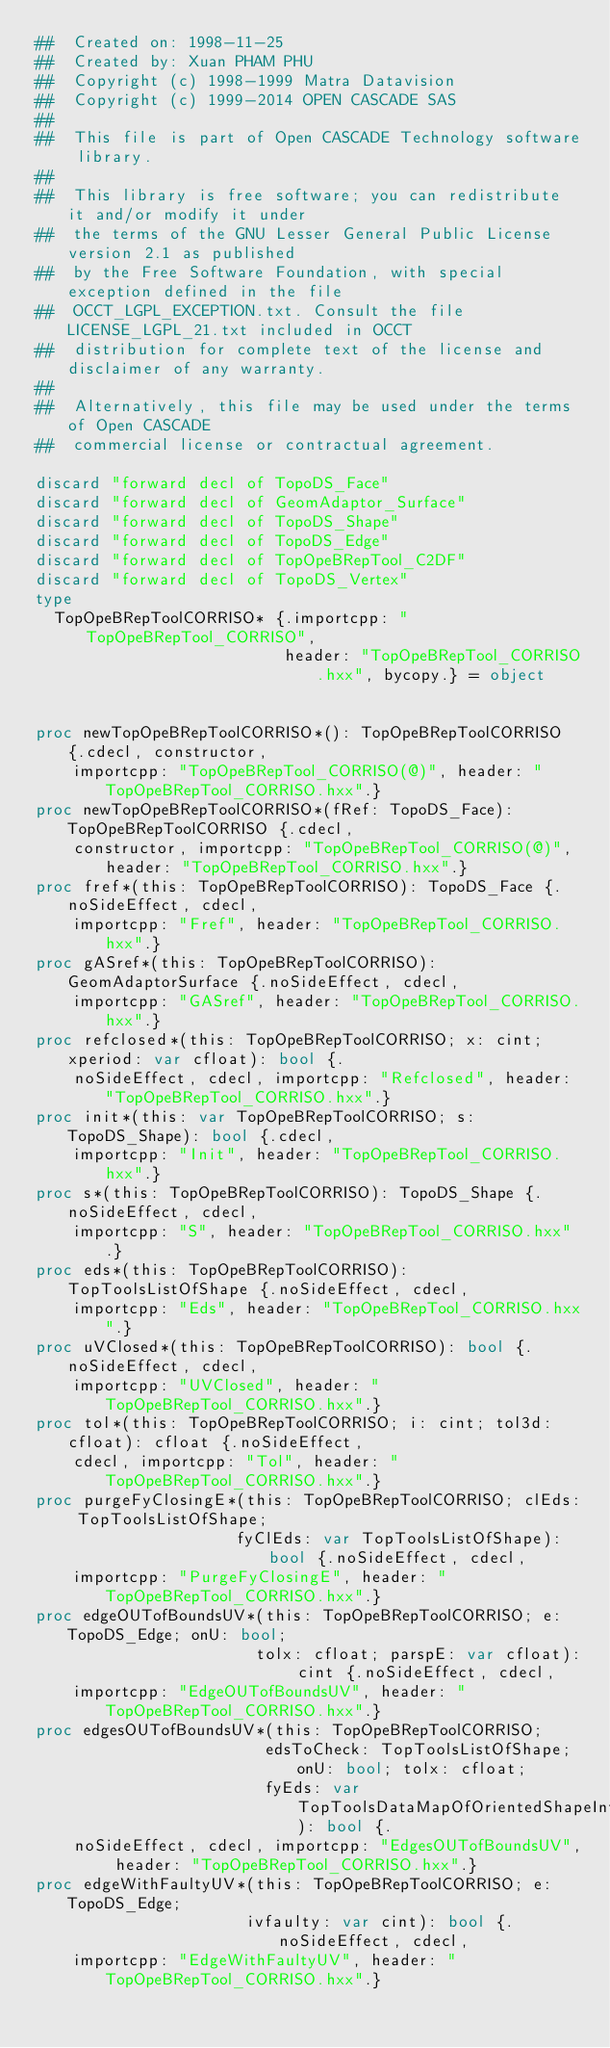Convert code to text. <code><loc_0><loc_0><loc_500><loc_500><_Nim_>##  Created on: 1998-11-25
##  Created by: Xuan PHAM PHU
##  Copyright (c) 1998-1999 Matra Datavision
##  Copyright (c) 1999-2014 OPEN CASCADE SAS
##
##  This file is part of Open CASCADE Technology software library.
##
##  This library is free software; you can redistribute it and/or modify it under
##  the terms of the GNU Lesser General Public License version 2.1 as published
##  by the Free Software Foundation, with special exception defined in the file
##  OCCT_LGPL_EXCEPTION.txt. Consult the file LICENSE_LGPL_21.txt included in OCCT
##  distribution for complete text of the license and disclaimer of any warranty.
##
##  Alternatively, this file may be used under the terms of Open CASCADE
##  commercial license or contractual agreement.

discard "forward decl of TopoDS_Face"
discard "forward decl of GeomAdaptor_Surface"
discard "forward decl of TopoDS_Shape"
discard "forward decl of TopoDS_Edge"
discard "forward decl of TopOpeBRepTool_C2DF"
discard "forward decl of TopoDS_Vertex"
type
  TopOpeBRepToolCORRISO* {.importcpp: "TopOpeBRepTool_CORRISO",
                          header: "TopOpeBRepTool_CORRISO.hxx", bycopy.} = object


proc newTopOpeBRepToolCORRISO*(): TopOpeBRepToolCORRISO {.cdecl, constructor,
    importcpp: "TopOpeBRepTool_CORRISO(@)", header: "TopOpeBRepTool_CORRISO.hxx".}
proc newTopOpeBRepToolCORRISO*(fRef: TopoDS_Face): TopOpeBRepToolCORRISO {.cdecl,
    constructor, importcpp: "TopOpeBRepTool_CORRISO(@)", header: "TopOpeBRepTool_CORRISO.hxx".}
proc fref*(this: TopOpeBRepToolCORRISO): TopoDS_Face {.noSideEffect, cdecl,
    importcpp: "Fref", header: "TopOpeBRepTool_CORRISO.hxx".}
proc gASref*(this: TopOpeBRepToolCORRISO): GeomAdaptorSurface {.noSideEffect, cdecl,
    importcpp: "GASref", header: "TopOpeBRepTool_CORRISO.hxx".}
proc refclosed*(this: TopOpeBRepToolCORRISO; x: cint; xperiod: var cfloat): bool {.
    noSideEffect, cdecl, importcpp: "Refclosed", header: "TopOpeBRepTool_CORRISO.hxx".}
proc init*(this: var TopOpeBRepToolCORRISO; s: TopoDS_Shape): bool {.cdecl,
    importcpp: "Init", header: "TopOpeBRepTool_CORRISO.hxx".}
proc s*(this: TopOpeBRepToolCORRISO): TopoDS_Shape {.noSideEffect, cdecl,
    importcpp: "S", header: "TopOpeBRepTool_CORRISO.hxx".}
proc eds*(this: TopOpeBRepToolCORRISO): TopToolsListOfShape {.noSideEffect, cdecl,
    importcpp: "Eds", header: "TopOpeBRepTool_CORRISO.hxx".}
proc uVClosed*(this: TopOpeBRepToolCORRISO): bool {.noSideEffect, cdecl,
    importcpp: "UVClosed", header: "TopOpeBRepTool_CORRISO.hxx".}
proc tol*(this: TopOpeBRepToolCORRISO; i: cint; tol3d: cfloat): cfloat {.noSideEffect,
    cdecl, importcpp: "Tol", header: "TopOpeBRepTool_CORRISO.hxx".}
proc purgeFyClosingE*(this: TopOpeBRepToolCORRISO; clEds: TopToolsListOfShape;
                     fyClEds: var TopToolsListOfShape): bool {.noSideEffect, cdecl,
    importcpp: "PurgeFyClosingE", header: "TopOpeBRepTool_CORRISO.hxx".}
proc edgeOUTofBoundsUV*(this: TopOpeBRepToolCORRISO; e: TopoDS_Edge; onU: bool;
                       tolx: cfloat; parspE: var cfloat): cint {.noSideEffect, cdecl,
    importcpp: "EdgeOUTofBoundsUV", header: "TopOpeBRepTool_CORRISO.hxx".}
proc edgesOUTofBoundsUV*(this: TopOpeBRepToolCORRISO;
                        edsToCheck: TopToolsListOfShape; onU: bool; tolx: cfloat;
                        fyEds: var TopToolsDataMapOfOrientedShapeInteger): bool {.
    noSideEffect, cdecl, importcpp: "EdgesOUTofBoundsUV", header: "TopOpeBRepTool_CORRISO.hxx".}
proc edgeWithFaultyUV*(this: TopOpeBRepToolCORRISO; e: TopoDS_Edge;
                      ivfaulty: var cint): bool {.noSideEffect, cdecl,
    importcpp: "EdgeWithFaultyUV", header: "TopOpeBRepTool_CORRISO.hxx".}</code> 